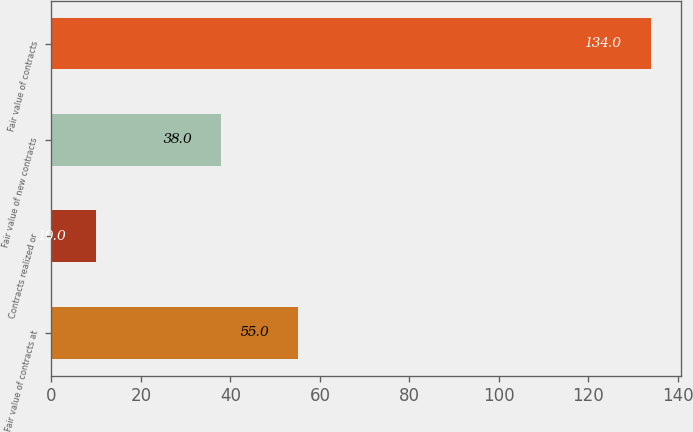Convert chart. <chart><loc_0><loc_0><loc_500><loc_500><bar_chart><fcel>Fair value of contracts at<fcel>Contracts realized or<fcel>Fair value of new contracts<fcel>Fair value of contracts<nl><fcel>55<fcel>10<fcel>38<fcel>134<nl></chart> 